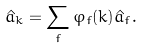<formula> <loc_0><loc_0><loc_500><loc_500>\hat { a } _ { k } = \sum _ { f } \varphi _ { f } ( k ) \hat { a } _ { f } .</formula> 